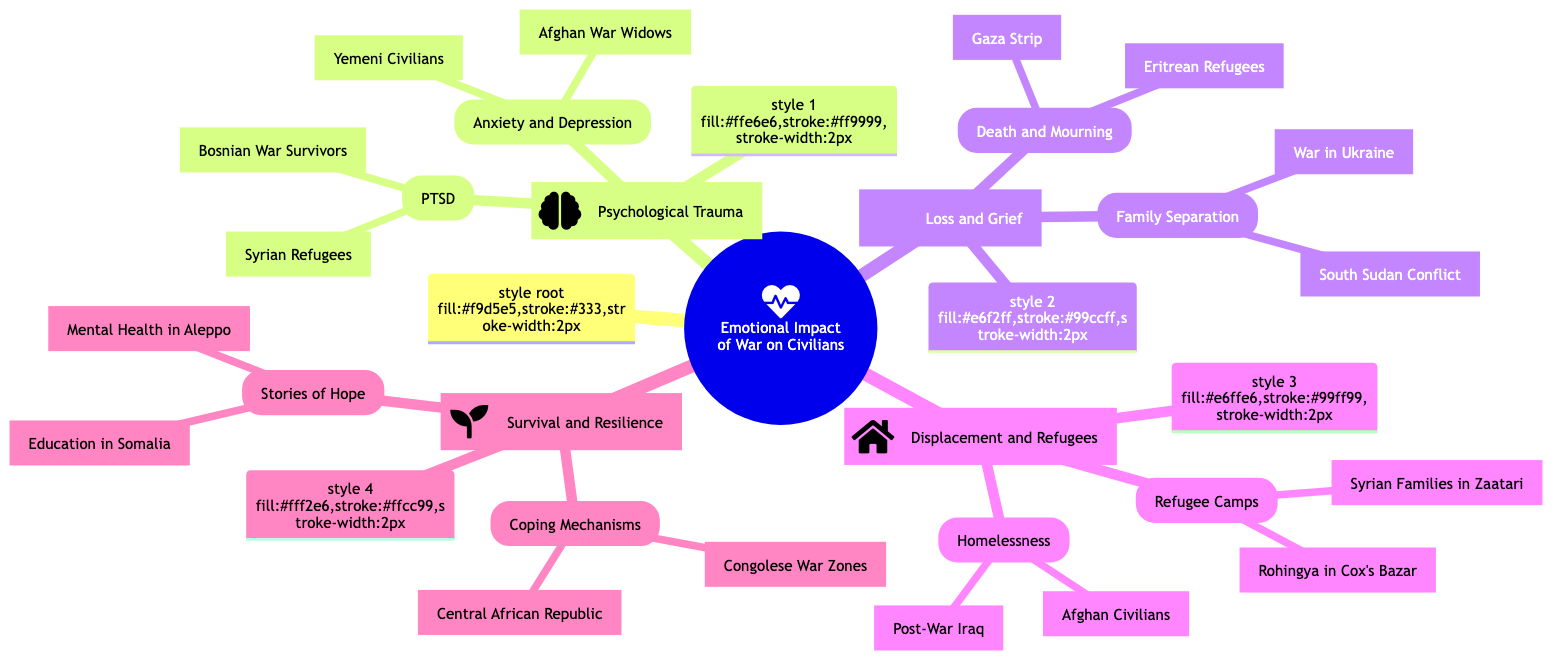What are the main sub-topics in the diagram? The diagram includes four main sub-topics under "Emotional Impact of War on Civilians": Psychological Trauma, Loss and Grief, Displacement and Refugees, and Survival and Resilience.
Answer: Psychological Trauma, Loss and Grief, Displacement and Refugees, Survival and Resilience How many case studies are listed under "Displacement and Refugees"? There are four case studies listed under "Displacement and Refugees": two under Refugee Camps and two under Homelessness.
Answer: 4 What type of trauma is associated with "Syrian Refugees"? The case studies related to "Syrian Refugees" specifically mention PTSD, which stands for Post-Traumatic Stress Disorder.
Answer: PTSD Which sub-topic contains stories about "Education Initiatives in War-Torn Somalia"? The story "Seeds of Change: Education Initiatives in War-Torn Somalia" is listed under the sub-topic "Survival and Resilience," specifically in the section "Stories of Hope."
Answer: Survival and Resilience How does "Afghan War Widows" relate to emotional impact? "Afghan War Widows" falls under the broader category of "Anxiety and Depression" within "Psychological Trauma," highlighting the emotional suffering experienced by widows during the conflict.
Answer: Anxiety and Depression What are the coping mechanisms highlighted in the diagram? The coping mechanisms discussed in the diagram include "Creative Outlets in Congolese War Zones" and "Grassroots Support in the Central African Republic."
Answer: Creative Outlets, Grassroots Support How many case studies are focused on loss and grief? The "Loss and Grief" section contains four case studies, including two on Family Separation and two on Death and Mourning.
Answer: 4 Which refugee camp is mentioned in connection with "Rohingya"? "Rohingya in Cox's Bazar" is the case study that connects to the refugee camp, reflecting on the conditions faced there.
Answer: Cox's Bazar What is the primary emotional impact addressed in this mind map? The primary emotional impact addressed in the mind map is the various forms of trauma, grief, displacement, and resilience experienced by civilians due to war.
Answer: Trauma, grief, displacement, resilience 